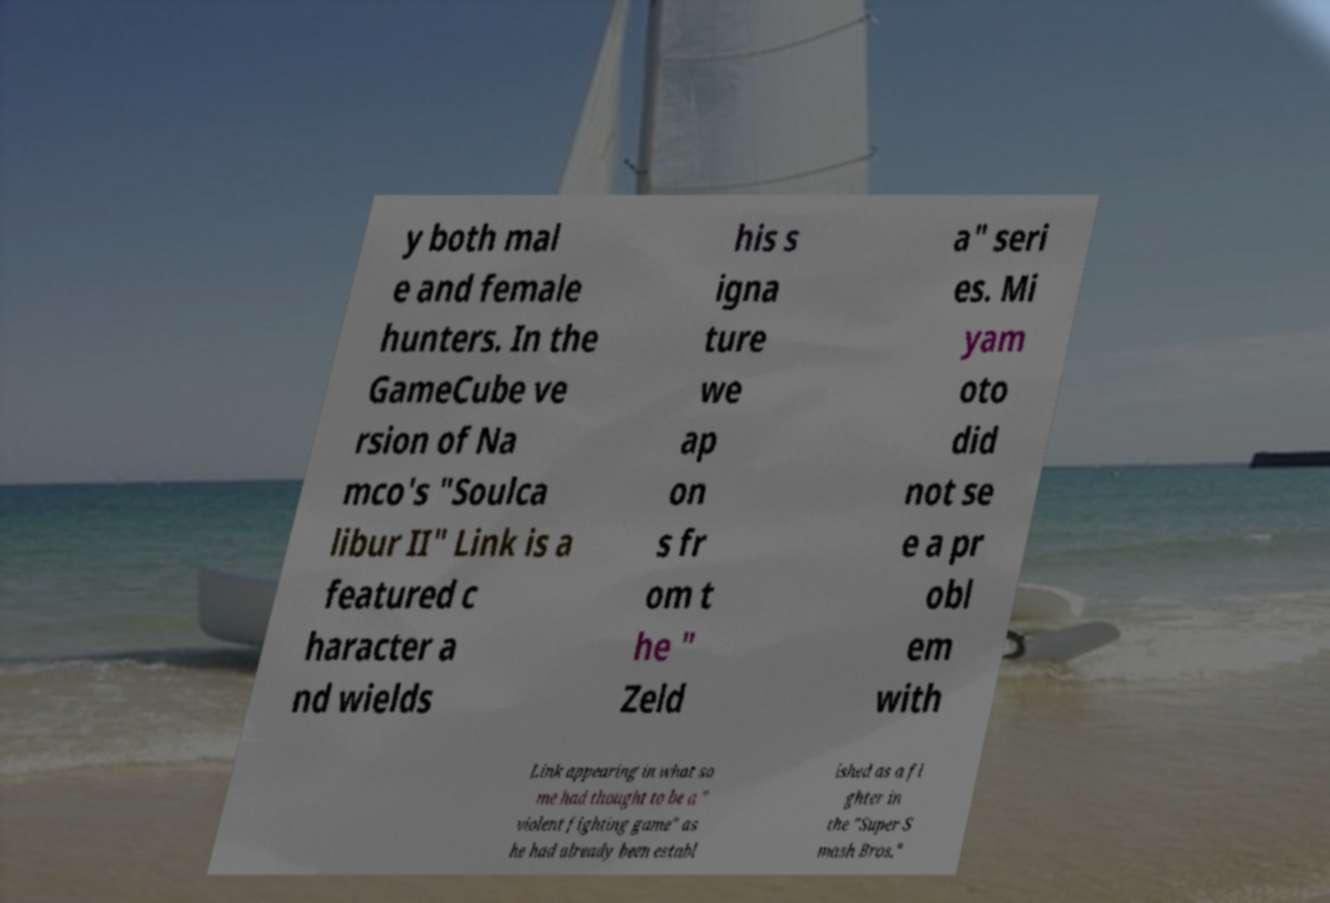There's text embedded in this image that I need extracted. Can you transcribe it verbatim? y both mal e and female hunters. In the GameCube ve rsion of Na mco's "Soulca libur II" Link is a featured c haracter a nd wields his s igna ture we ap on s fr om t he " Zeld a" seri es. Mi yam oto did not se e a pr obl em with Link appearing in what so me had thought to be a " violent fighting game" as he had already been establ ished as a fi ghter in the "Super S mash Bros." 